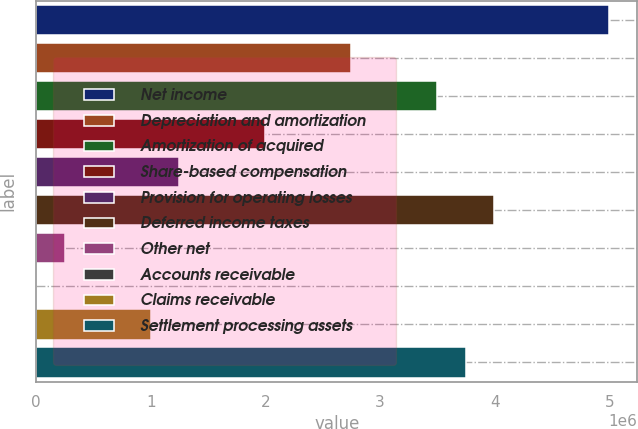Convert chart to OTSL. <chart><loc_0><loc_0><loc_500><loc_500><bar_chart><fcel>Net income<fcel>Depreciation and amortization<fcel>Amortization of acquired<fcel>Share-based compensation<fcel>Provision for operating losses<fcel>Deferred income taxes<fcel>Other net<fcel>Accounts receivable<fcel>Claims receivable<fcel>Settlement processing assets<nl><fcel>4.99244e+06<fcel>2.7464e+06<fcel>3.49508e+06<fcel>1.99772e+06<fcel>1.24904e+06<fcel>3.9942e+06<fcel>250807<fcel>1248<fcel>999486<fcel>3.74464e+06<nl></chart> 